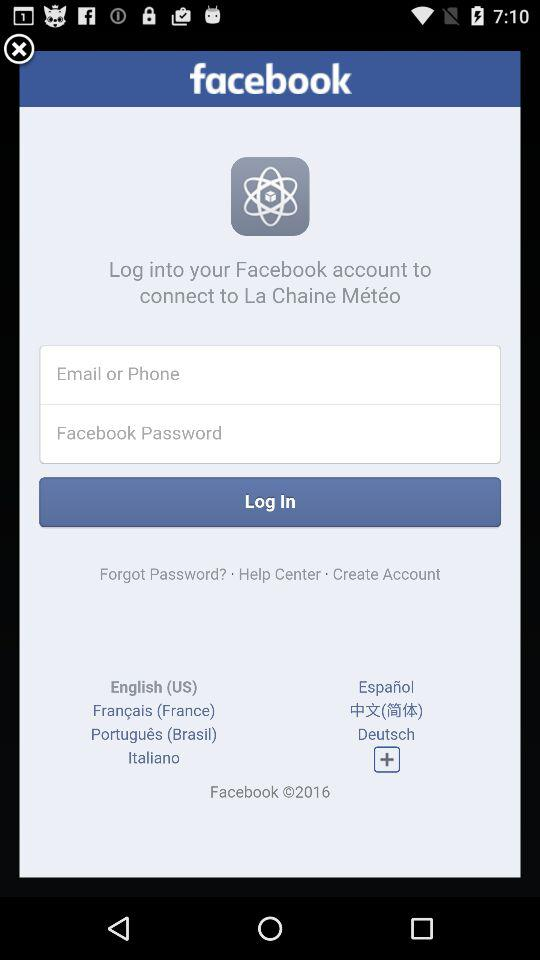What is the application name? The application name is "facebook". 